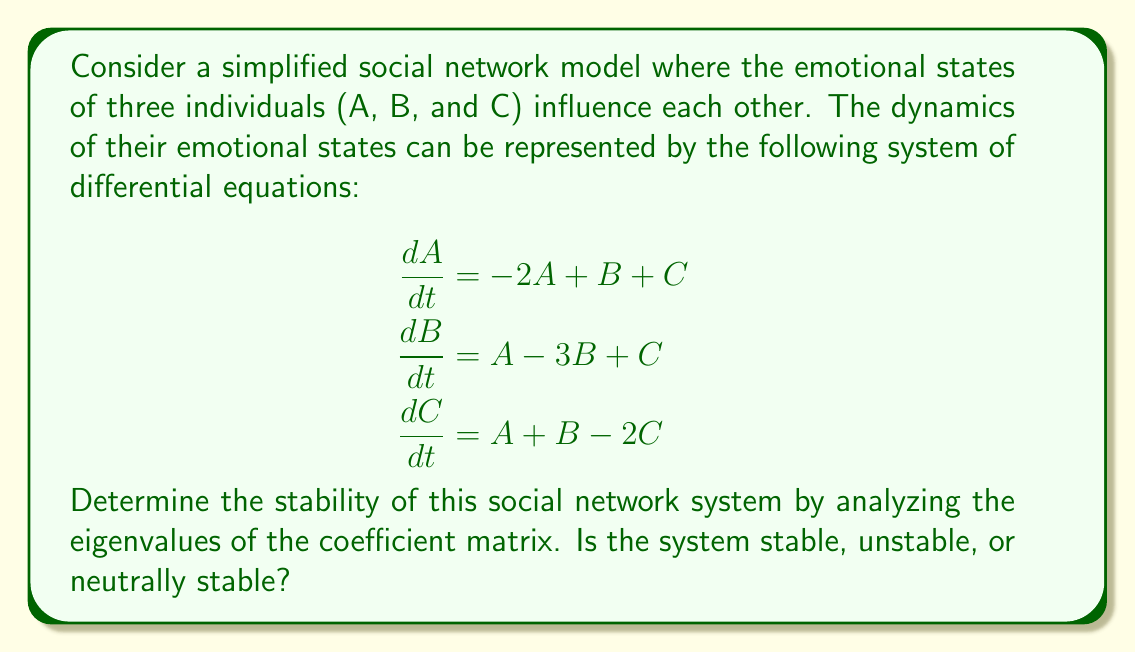What is the answer to this math problem? To analyze the stability of this social network system, we need to follow these steps:

1. Identify the coefficient matrix from the system of differential equations:

$$A = \begin{bmatrix}
-2 & 1 & 1 \\
1 & -3 & 1 \\
1 & 1 & -2
\end{bmatrix}$$

2. Calculate the characteristic equation:
   $det(A - \lambda I) = 0$

   $$\begin{vmatrix}
   -2-\lambda & 1 & 1 \\
   1 & -3-\lambda & 1 \\
   1 & 1 & -2-\lambda
   \end{vmatrix} = 0$$

3. Expand the determinant:
   $(-2-\lambda)[(-3-\lambda)(-2-\lambda) - 1] - 1[1(-2-\lambda) - 1(1)] + 1[1(1) - (-3-\lambda)(1)] = 0$

4. Simplify:
   $(-2-\lambda)[(6+5\lambda+\lambda^2) - 1] - [-2-\lambda - 1] + [1 + 3 + \lambda] = 0$
   $(-2-\lambda)(5+5\lambda+\lambda^2) + 3 + \lambda + 4 + \lambda = 0$
   $-10-10\lambda-2\lambda^2-5\lambda-5\lambda^2-\lambda^3 + 7 + 2\lambda = 0$

5. Collect terms:
   $-\lambda^3 - 7\lambda^2 - 13\lambda - 3 = 0$

6. Solve for the eigenvalues:
   The roots of this cubic equation are approximately:
   $\lambda_1 \approx -4.79$
   $\lambda_2 \approx -1.21$
   $\lambda_3 \approx -0.99$

7. Analyze the stability:
   All eigenvalues are real and negative. In a dynamical system, this indicates that all modes of the system decay over time, leading to a stable equilibrium point.
Answer: The system is stable. 